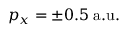<formula> <loc_0><loc_0><loc_500><loc_500>p _ { x } = \pm 0 . 5 \, a . u .</formula> 